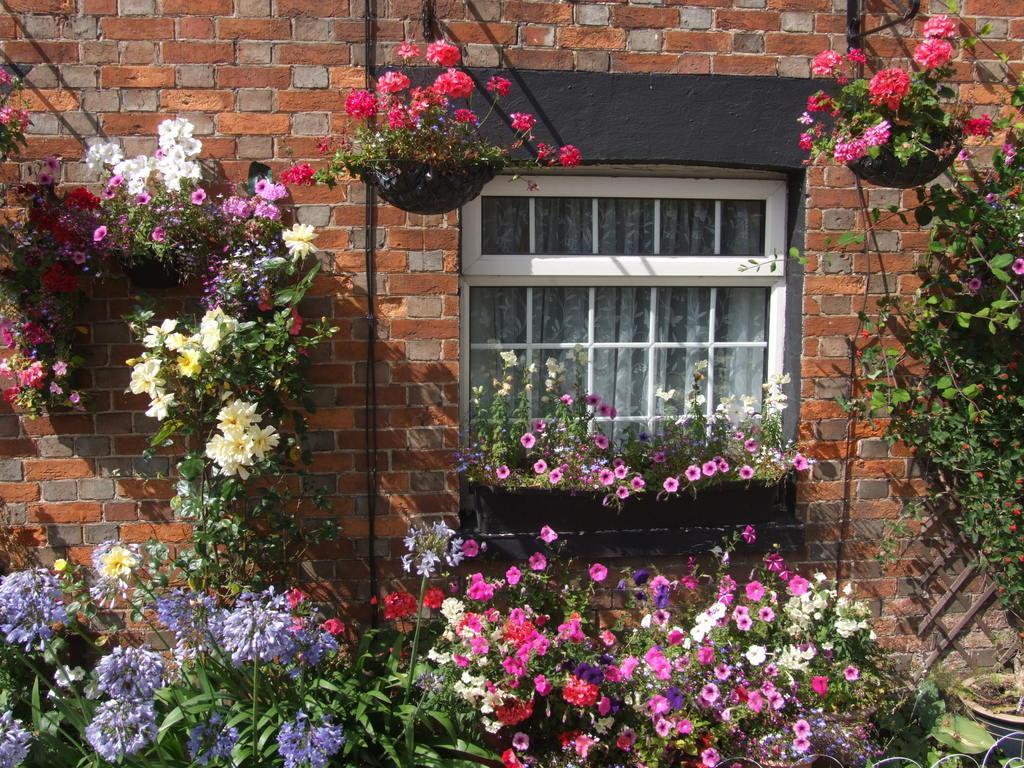Could you give a brief overview of what you see in this image? In the image there is a window on middle of the brick wall with many flower plants all around it. 